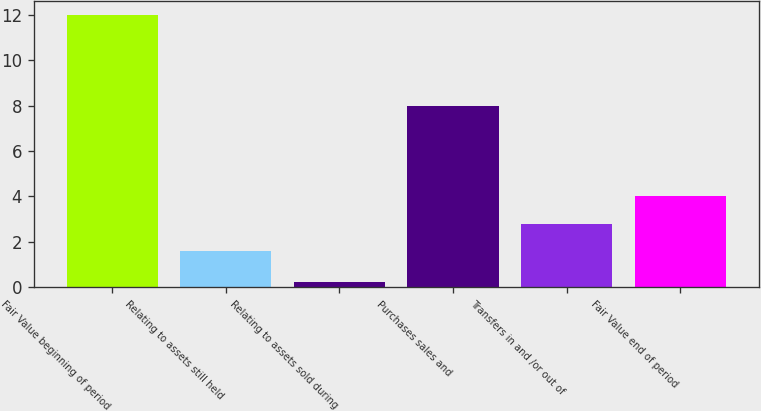<chart> <loc_0><loc_0><loc_500><loc_500><bar_chart><fcel>Fair Value beginning of period<fcel>Relating to assets still held<fcel>Relating to assets sold during<fcel>Purchases sales and<fcel>Transfers in and /or out of<fcel>Fair Value end of period<nl><fcel>12<fcel>1.61<fcel>0.22<fcel>8<fcel>2.79<fcel>4<nl></chart> 